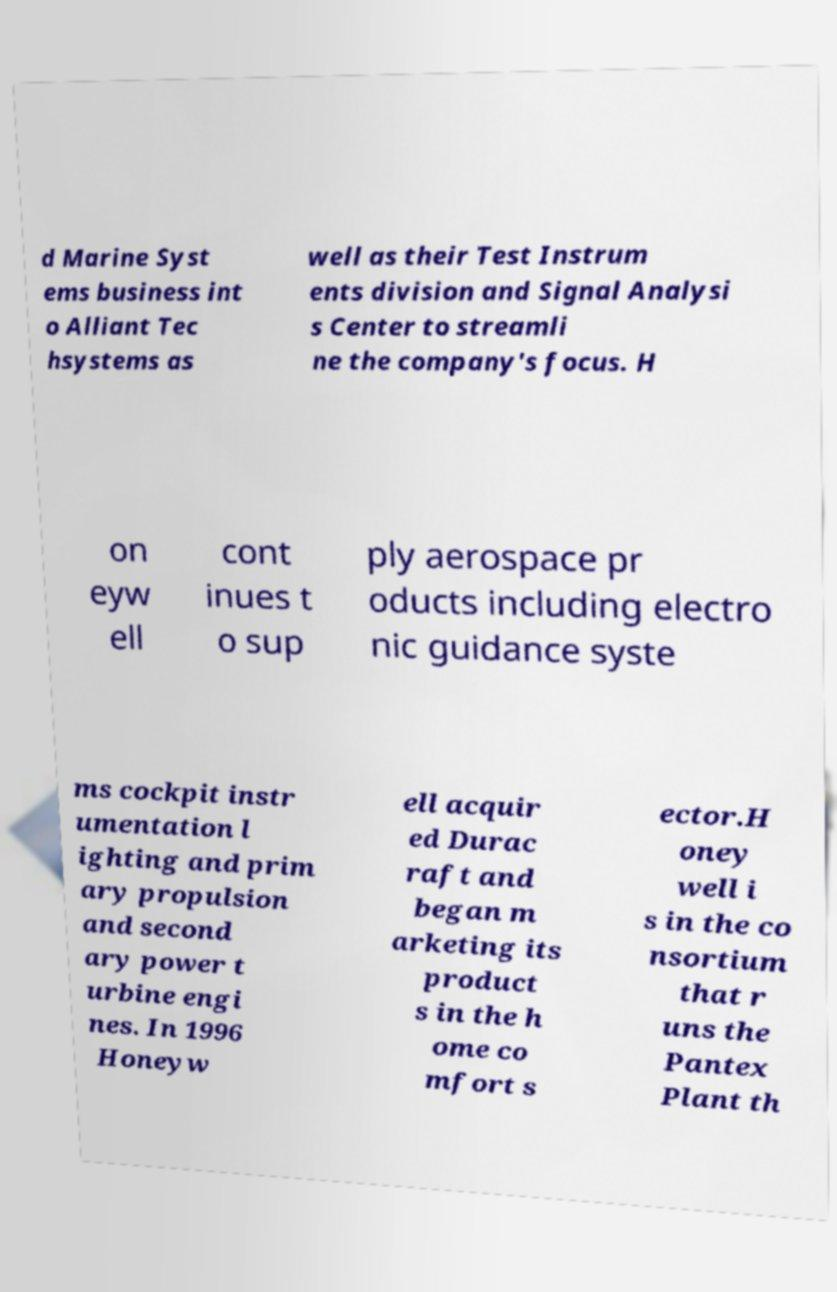Can you read and provide the text displayed in the image?This photo seems to have some interesting text. Can you extract and type it out for me? d Marine Syst ems business int o Alliant Tec hsystems as well as their Test Instrum ents division and Signal Analysi s Center to streamli ne the company's focus. H on eyw ell cont inues t o sup ply aerospace pr oducts including electro nic guidance syste ms cockpit instr umentation l ighting and prim ary propulsion and second ary power t urbine engi nes. In 1996 Honeyw ell acquir ed Durac raft and began m arketing its product s in the h ome co mfort s ector.H oney well i s in the co nsortium that r uns the Pantex Plant th 